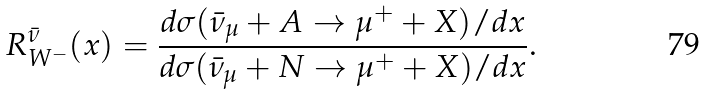<formula> <loc_0><loc_0><loc_500><loc_500>R ^ { \bar { \nu } } _ { W ^ { - } } ( x ) = \frac { d \sigma ( \bar { \nu } _ { \mu } + A \to \mu ^ { + } + X ) / d x } { d \sigma ( \bar { \nu } _ { \mu } + N \to \mu ^ { + } + X ) / d x } .</formula> 